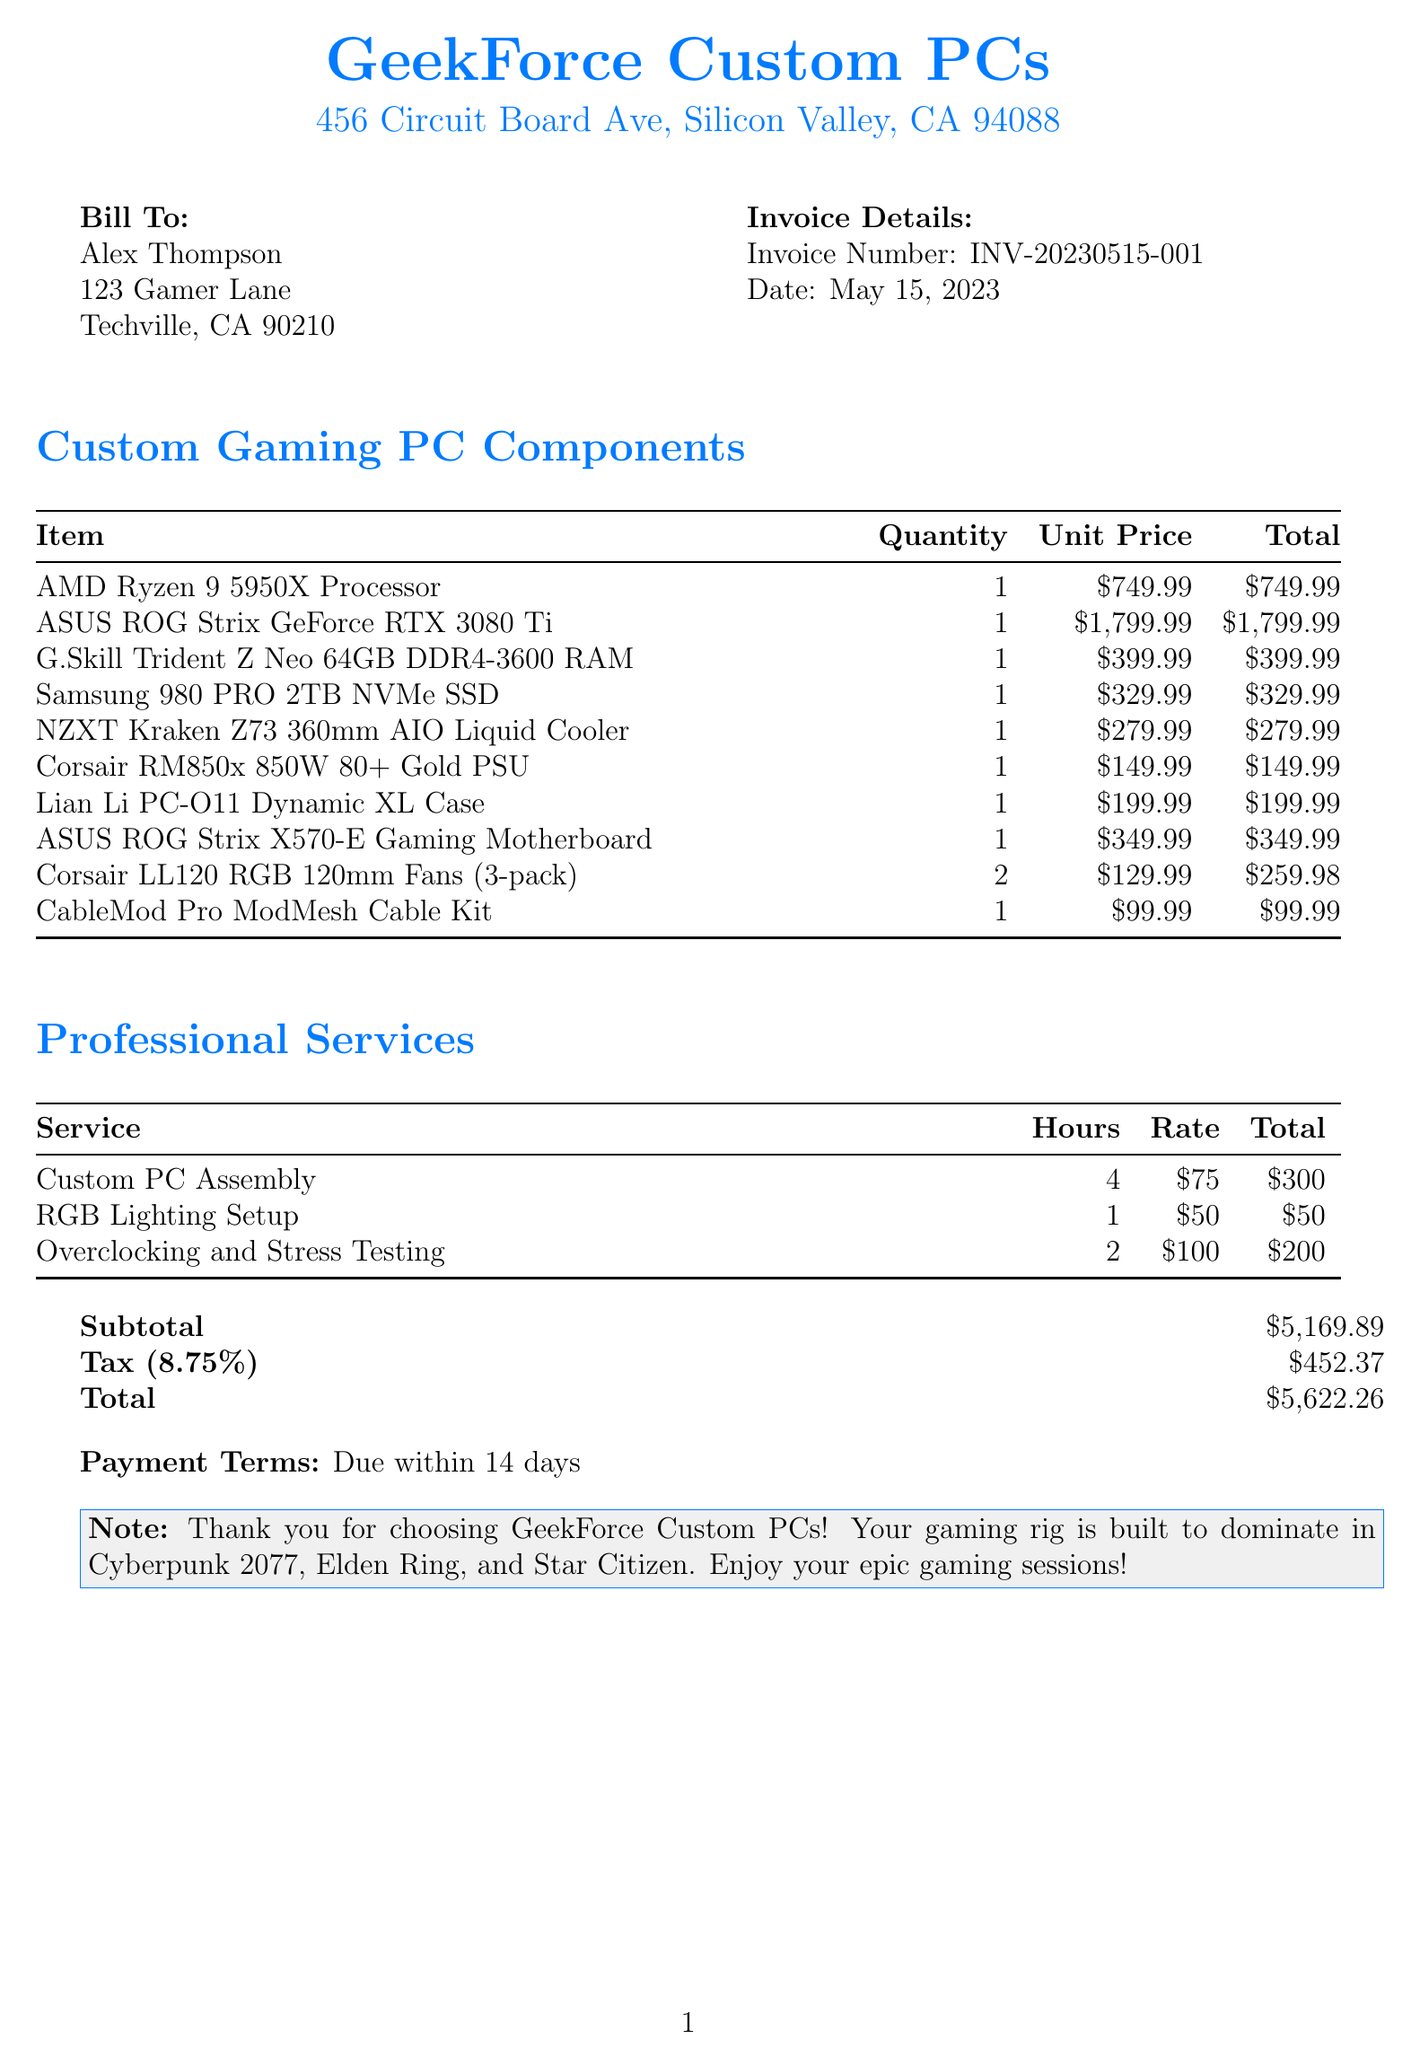what is the invoice number? The invoice number is explicitly mentioned in the document.
Answer: INV-20230515-001 who is the customer? The customer's name is listed at the top of the invoice.
Answer: Alex Thompson what is the subtotal amount? The subtotal amount is clearly stated in the document under the financial summary.
Answer: $5,169.89 how many RGB fans were purchased? The quantity of RGB fans is noted in the components section of the invoice.
Answer: 2 what service has the highest hourly rate? The services listed have different hourly rates, and the highest can be identified from the services section.
Answer: Overclocking and Stress Testing what is the tax rate applied? The tax rate is specified in the financial summary of the document.
Answer: 8.75% how much was charged for custom PC assembly? The total cost for this service is mentioned in the services section.
Answer: $300 what is the payment term for this invoice? The payment terms are outlined towards the end of the invoice.
Answer: Due within 14 days what cooling solution is included in the build? The cooling solution is detailed in the components section of the invoice.
Answer: NZXT Kraken Z73 360mm AIO Liquid Cooler 